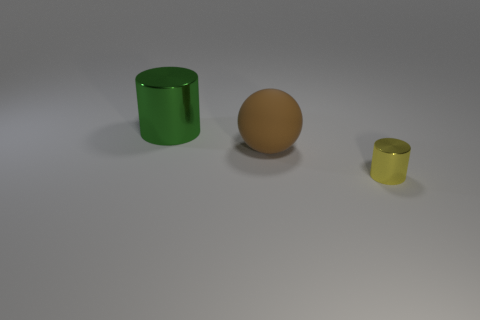Subtract all balls. How many objects are left? 2 Add 3 large brown cubes. How many objects exist? 6 Subtract all big balls. Subtract all big matte balls. How many objects are left? 1 Add 1 large things. How many large things are left? 3 Add 1 big shiny cylinders. How many big shiny cylinders exist? 2 Subtract 0 cyan blocks. How many objects are left? 3 